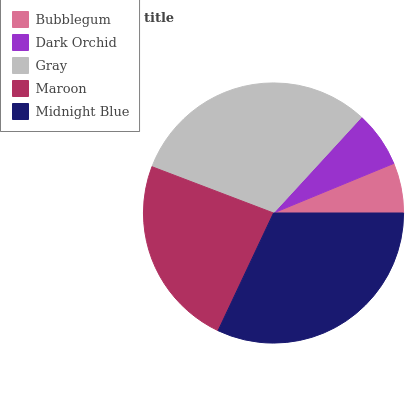Is Bubblegum the minimum?
Answer yes or no. Yes. Is Midnight Blue the maximum?
Answer yes or no. Yes. Is Dark Orchid the minimum?
Answer yes or no. No. Is Dark Orchid the maximum?
Answer yes or no. No. Is Dark Orchid greater than Bubblegum?
Answer yes or no. Yes. Is Bubblegum less than Dark Orchid?
Answer yes or no. Yes. Is Bubblegum greater than Dark Orchid?
Answer yes or no. No. Is Dark Orchid less than Bubblegum?
Answer yes or no. No. Is Maroon the high median?
Answer yes or no. Yes. Is Maroon the low median?
Answer yes or no. Yes. Is Bubblegum the high median?
Answer yes or no. No. Is Dark Orchid the low median?
Answer yes or no. No. 